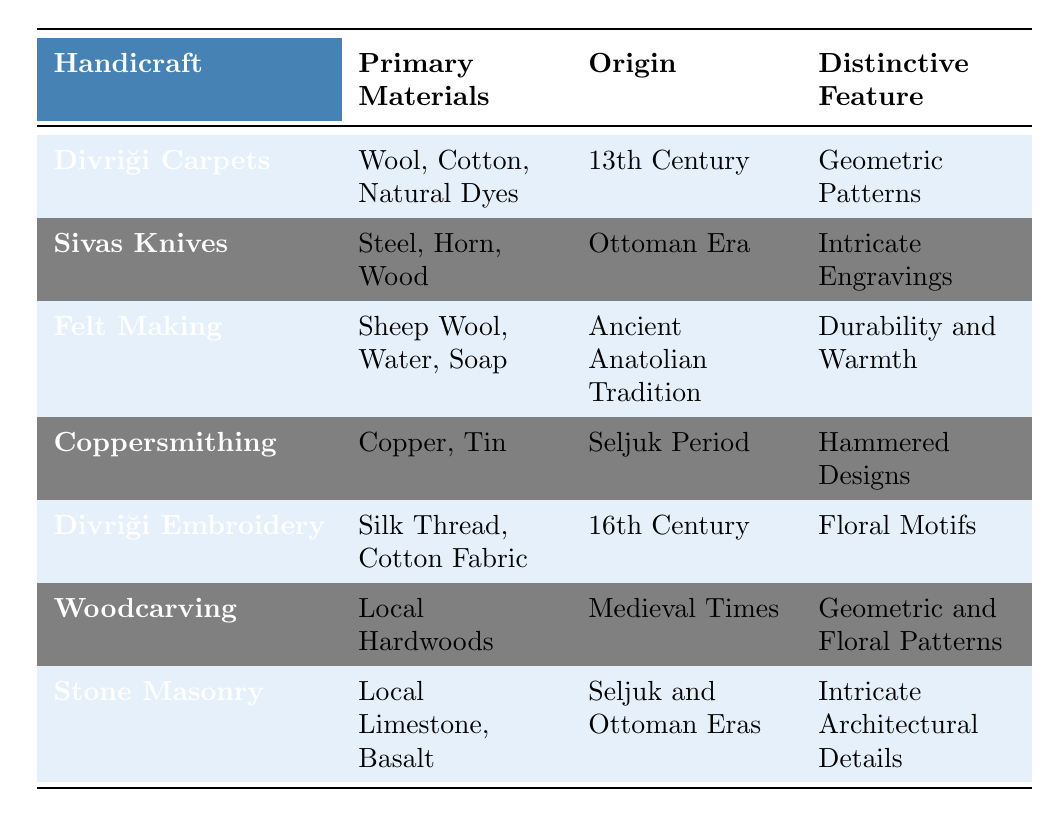What are the primary materials used in Divriği Carpets? Looking at the table, the specific row for Divriği Carpets lists "Wool, Cotton, Natural Dyes" under the Primary Materials column.
Answer: Wool, Cotton, Natural Dyes Which handicraft originated in the 13th Century? Referring to the table, the handicraft that is marked with the origin of the 13th Century is Divriği Carpets, as indicated in the Origin column.
Answer: Divriği Carpets Is felt making part of a more ancient tradition or a modern one? The table states that Felt Making originates from the Ancient Anatolian Tradition, indicating it is part of a more ancient tradition.
Answer: Ancient What distinctive feature do Sivas Knives have? From the table, the distinctive feature for Sivas Knives is noted as "Intricate Engravings" in the Distinctive Feature column.
Answer: Intricate Engravings Which handicraft uses Silk Thread as a primary material? According to the table, the only handicraft listed with Silk Thread as a primary material is Divriği Embroidery, confirmed by its presence in the Primary Materials column.
Answer: Divriği Embroidery How many handicrafts originate from the Seljuk Period? The table provides information on two handicrafts: Coppersmithing and Stone Masonry, both of which are associated with the Seljuk Period in the Origin column. Thus, the total is two.
Answer: 2 What is the distinctive feature of Woodcarving? The table indicates that Woodcarving has "Geometric and Floral Patterns" as its distinctive feature, which can be found in the Distinctive Feature column.
Answer: Geometric and Floral Patterns Do any of the handicrafts have floral motifs as a distinctive feature? Yes, Divriği Embroidery, as listed in the table, has floral motifs as its distinctive feature, confirming the presence of floral motifs among the handicrafts.
Answer: Yes Which handicraft has the strongest materials based on the table? Analyzing the materials, Sivas Knives use Steel, Horn, and Wood, which are generally considered stronger materials, compared to others like Wool or Cotton. Thus, Sivas Knives are noted for having strongly built materials.
Answer: Sivas Knives What is the average number of primary materials for the listed handicrafts? Counting the primary materials for each handicraft gives us the following totals: Divriği Carpets (3), Sivas Knives (3), Felt Making (3), Coppersmithing (2), Divriği Embroidery (2), Woodcarving (1), Stone Masonry (2). The sums up to 16 materials. There are 7 handicrafts (16/7), giving an average of approximately 2.29 materials per handicraft.
Answer: 2.29 